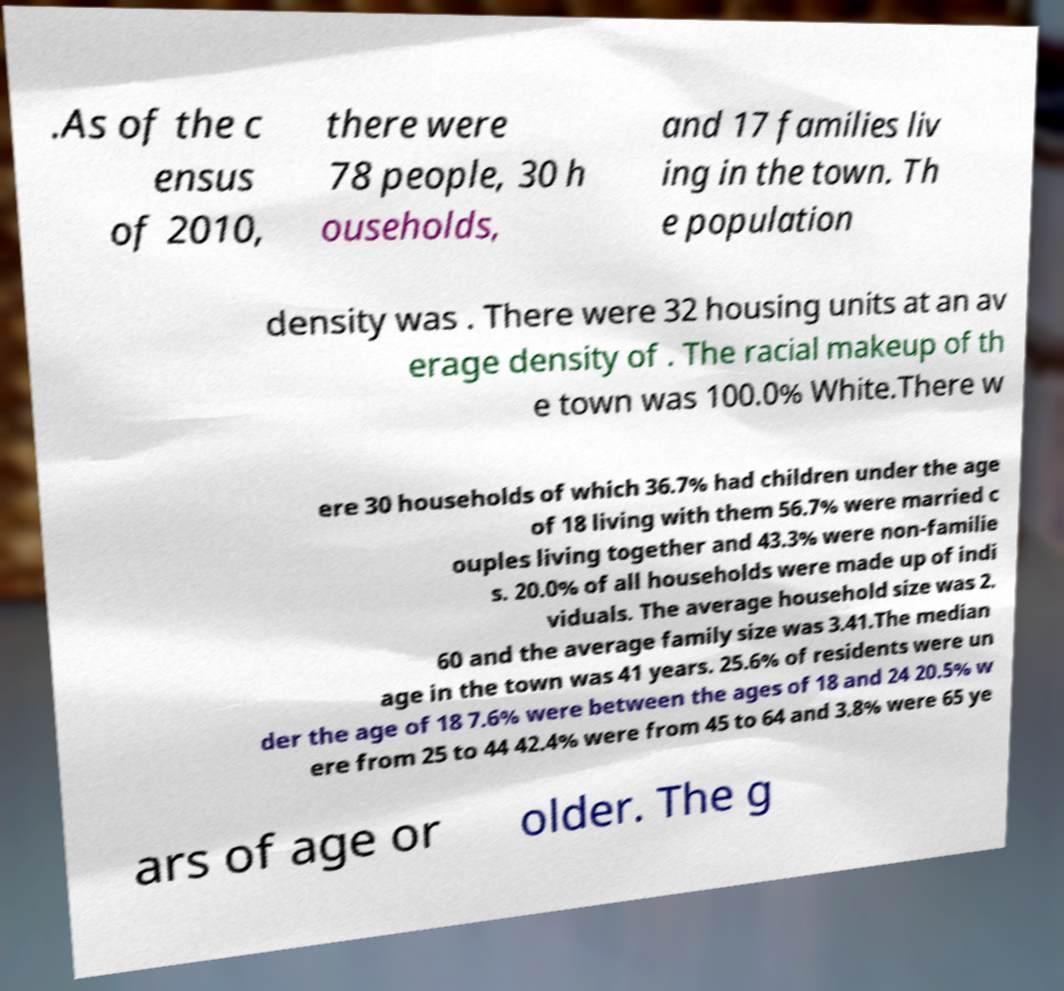Can you accurately transcribe the text from the provided image for me? .As of the c ensus of 2010, there were 78 people, 30 h ouseholds, and 17 families liv ing in the town. Th e population density was . There were 32 housing units at an av erage density of . The racial makeup of th e town was 100.0% White.There w ere 30 households of which 36.7% had children under the age of 18 living with them 56.7% were married c ouples living together and 43.3% were non-familie s. 20.0% of all households were made up of indi viduals. The average household size was 2. 60 and the average family size was 3.41.The median age in the town was 41 years. 25.6% of residents were un der the age of 18 7.6% were between the ages of 18 and 24 20.5% w ere from 25 to 44 42.4% were from 45 to 64 and 3.8% were 65 ye ars of age or older. The g 